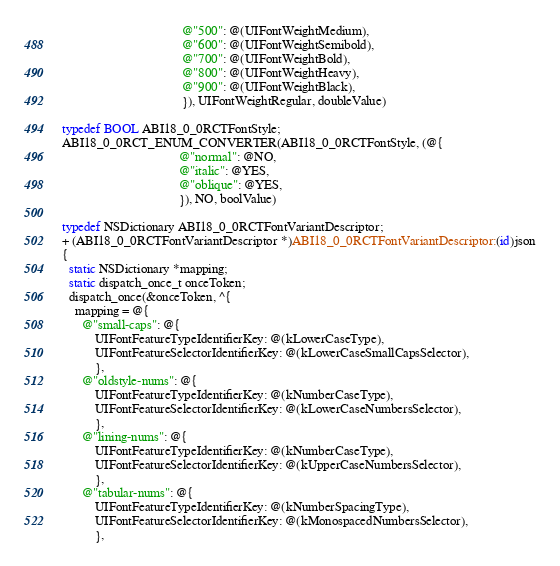<code> <loc_0><loc_0><loc_500><loc_500><_ObjectiveC_>                                     @"500": @(UIFontWeightMedium),
                                     @"600": @(UIFontWeightSemibold),
                                     @"700": @(UIFontWeightBold),
                                     @"800": @(UIFontWeightHeavy),
                                     @"900": @(UIFontWeightBlack),
                                     }), UIFontWeightRegular, doubleValue)

typedef BOOL ABI18_0_0RCTFontStyle;
ABI18_0_0RCT_ENUM_CONVERTER(ABI18_0_0RCTFontStyle, (@{
                                    @"normal": @NO,
                                    @"italic": @YES,
                                    @"oblique": @YES,
                                    }), NO, boolValue)

typedef NSDictionary ABI18_0_0RCTFontVariantDescriptor;
+ (ABI18_0_0RCTFontVariantDescriptor *)ABI18_0_0RCTFontVariantDescriptor:(id)json
{
  static NSDictionary *mapping;
  static dispatch_once_t onceToken;
  dispatch_once(&onceToken, ^{
    mapping = @{
      @"small-caps": @{
          UIFontFeatureTypeIdentifierKey: @(kLowerCaseType),
          UIFontFeatureSelectorIdentifierKey: @(kLowerCaseSmallCapsSelector),
          },
      @"oldstyle-nums": @{
          UIFontFeatureTypeIdentifierKey: @(kNumberCaseType),
          UIFontFeatureSelectorIdentifierKey: @(kLowerCaseNumbersSelector),
          },
      @"lining-nums": @{
          UIFontFeatureTypeIdentifierKey: @(kNumberCaseType),
          UIFontFeatureSelectorIdentifierKey: @(kUpperCaseNumbersSelector),
          },
      @"tabular-nums": @{
          UIFontFeatureTypeIdentifierKey: @(kNumberSpacingType),
          UIFontFeatureSelectorIdentifierKey: @(kMonospacedNumbersSelector),
          },</code> 